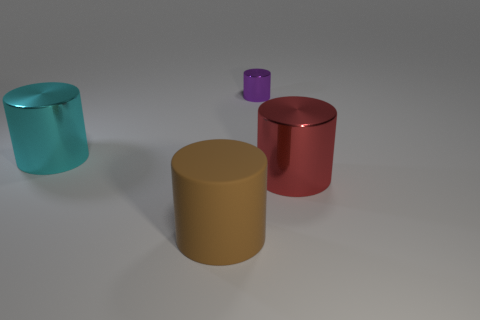Subtract 1 cylinders. How many cylinders are left? 3 Add 1 small red spheres. How many objects exist? 5 Add 2 big objects. How many big objects exist? 5 Subtract 1 cyan cylinders. How many objects are left? 3 Subtract all matte things. Subtract all small purple metal objects. How many objects are left? 2 Add 4 large red metallic things. How many large red metallic things are left? 5 